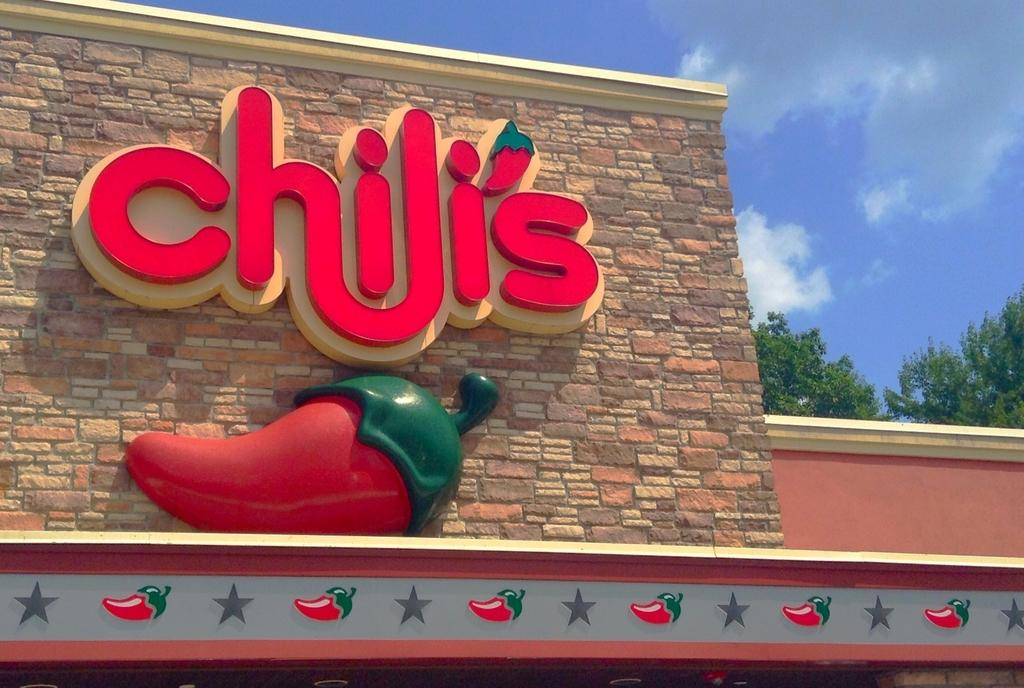What is present on the wall in the image? There is text on the wall in the image. What can be seen on the right side of the image? There are trees on the right side of the image. What is visible in the sky in the background of the image? There are clouds in the sky in the background of the image. What type of soup is being served in the image? There is no soup present in the image. What color are the trousers worn by the tree on the right side of the image? Trees do not wear trousers, and there is no tree wearing trousers in the image. 